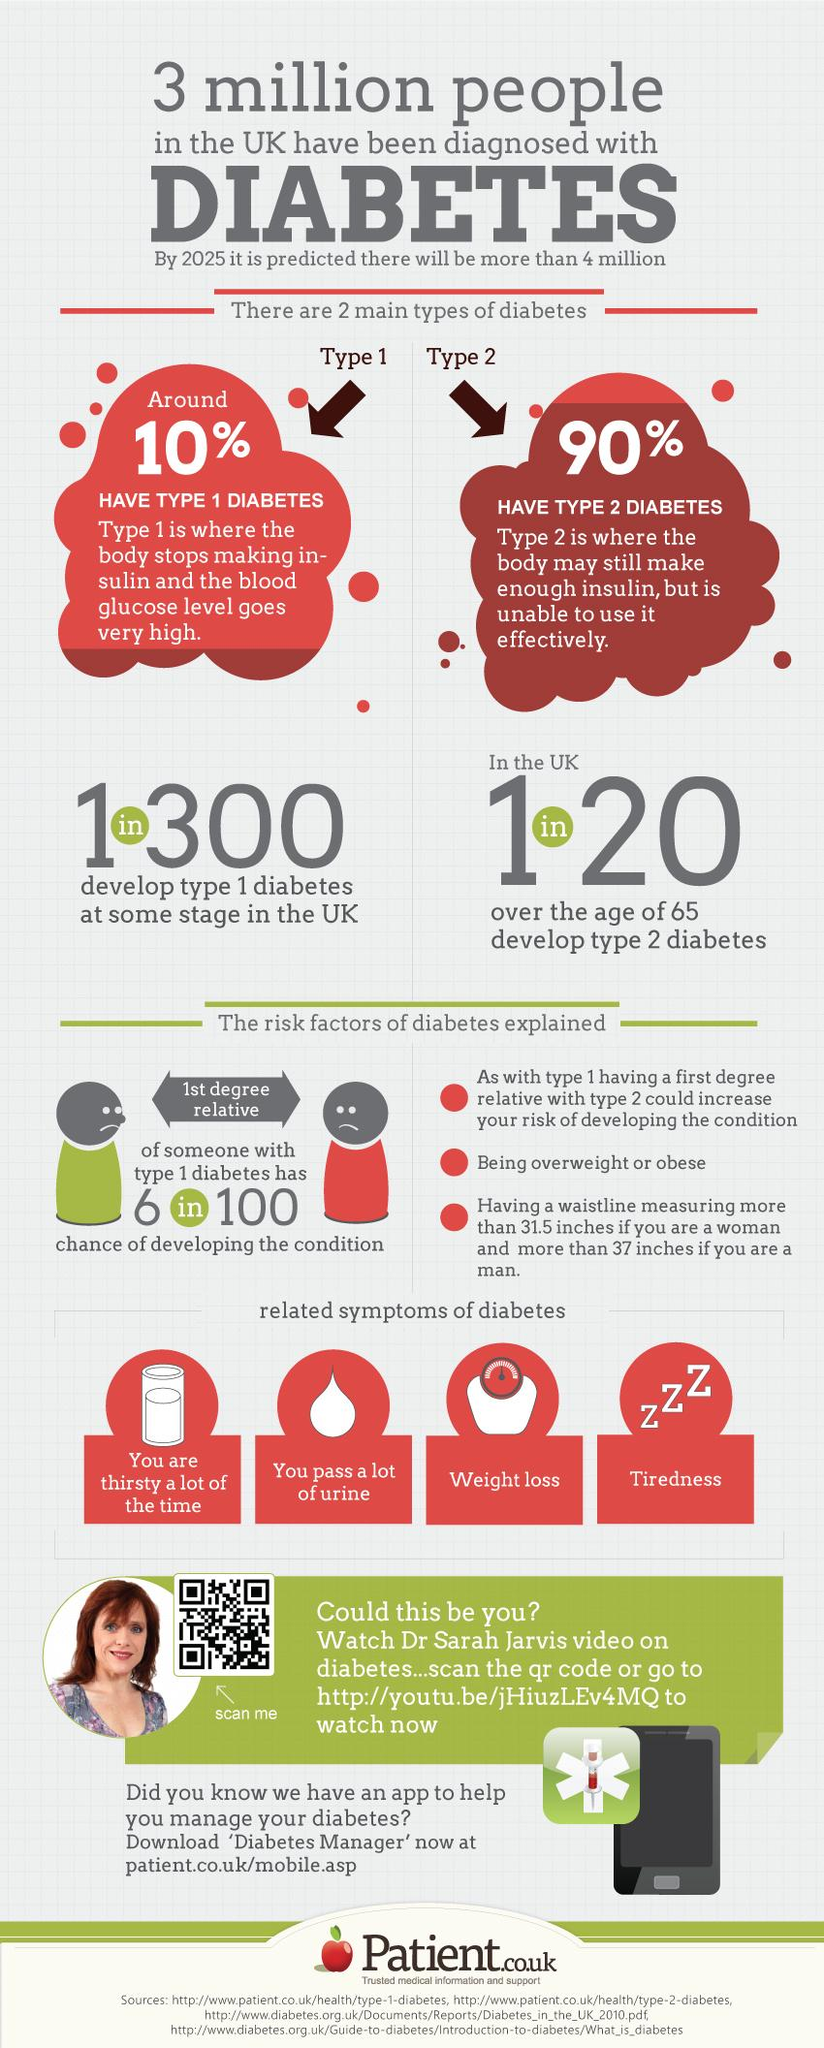Indicate a few pertinent items in this graphic. It is more common for senior citizens to have Type 2 diabetes. Type 1 diabetes is a form of the disease that does not have an age limit and can occur at any time. 